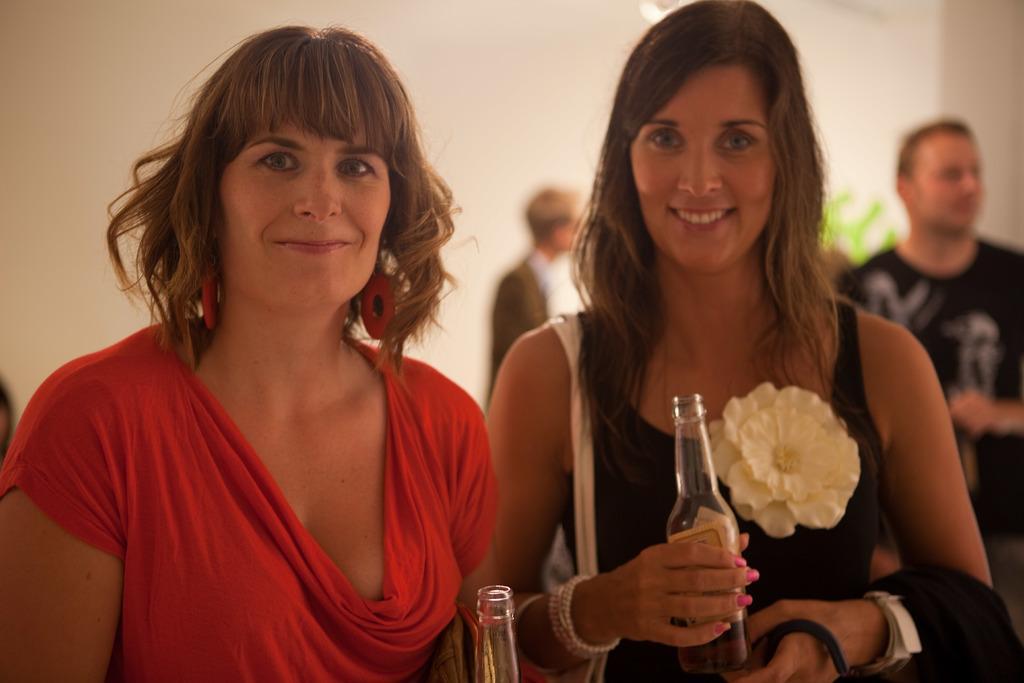Describe this image in one or two sentences. In the image there are two women stood beside each other holding beer bottles over the background there are two men. 